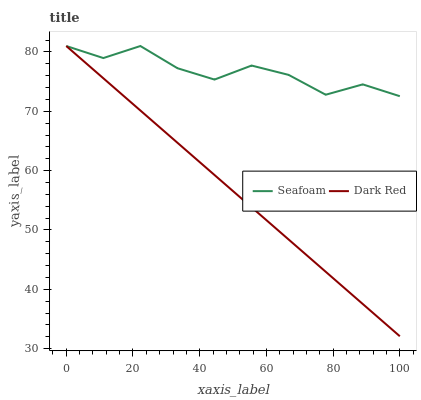Does Dark Red have the minimum area under the curve?
Answer yes or no. Yes. Does Seafoam have the maximum area under the curve?
Answer yes or no. Yes. Does Seafoam have the minimum area under the curve?
Answer yes or no. No. Is Dark Red the smoothest?
Answer yes or no. Yes. Is Seafoam the roughest?
Answer yes or no. Yes. Is Seafoam the smoothest?
Answer yes or no. No. Does Dark Red have the lowest value?
Answer yes or no. Yes. Does Seafoam have the lowest value?
Answer yes or no. No. Does Seafoam have the highest value?
Answer yes or no. Yes. Does Seafoam intersect Dark Red?
Answer yes or no. Yes. Is Seafoam less than Dark Red?
Answer yes or no. No. Is Seafoam greater than Dark Red?
Answer yes or no. No. 